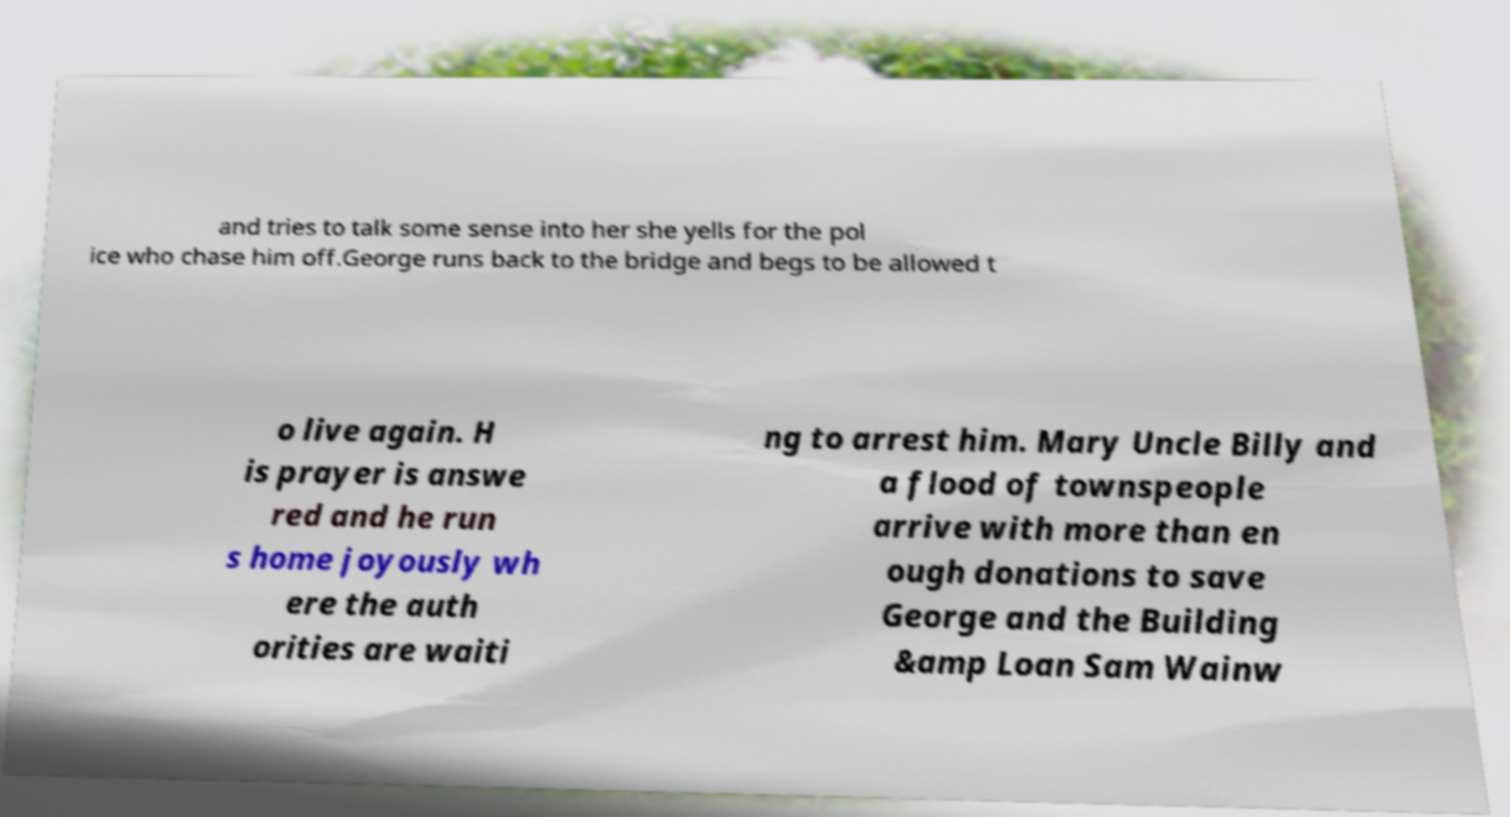Please read and relay the text visible in this image. What does it say? and tries to talk some sense into her she yells for the pol ice who chase him off.George runs back to the bridge and begs to be allowed t o live again. H is prayer is answe red and he run s home joyously wh ere the auth orities are waiti ng to arrest him. Mary Uncle Billy and a flood of townspeople arrive with more than en ough donations to save George and the Building &amp Loan Sam Wainw 